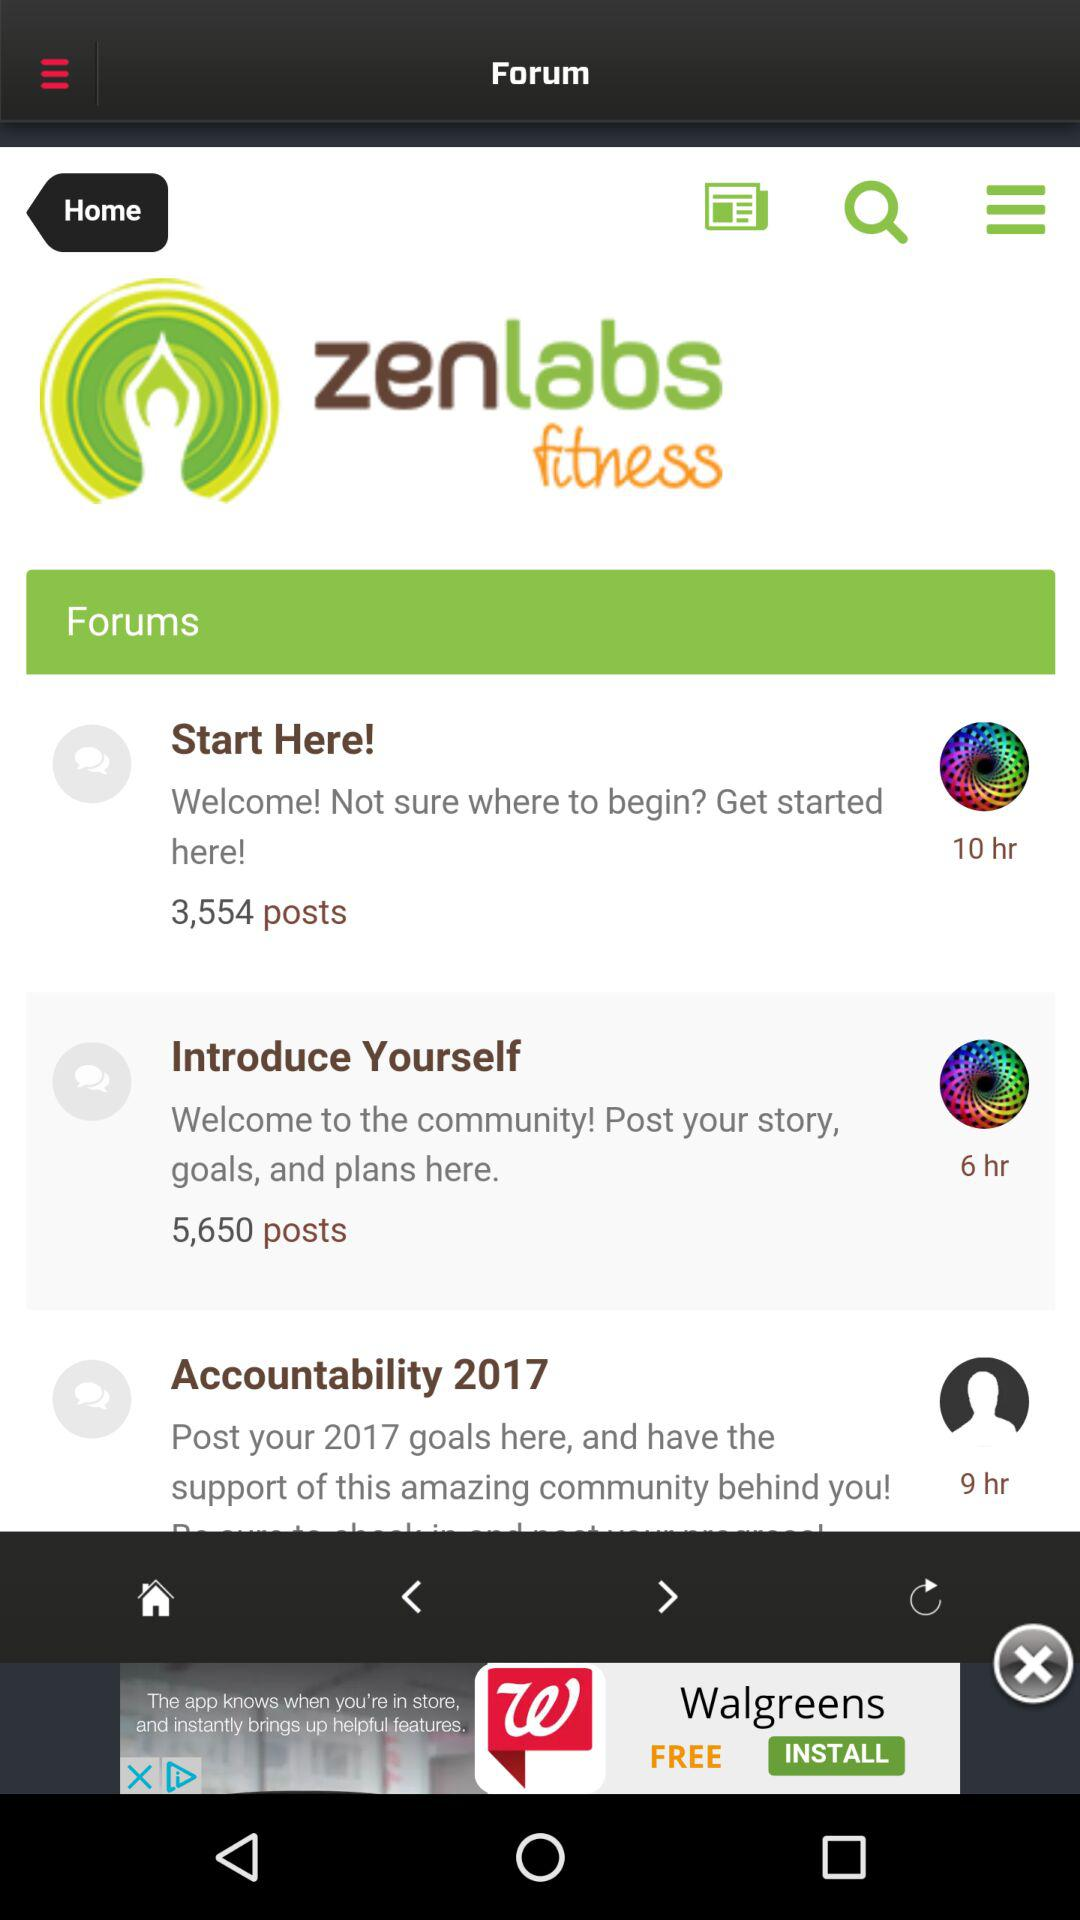When was the accountability 2017 posted? The accountability 2017 was posted 9 hours ago. 